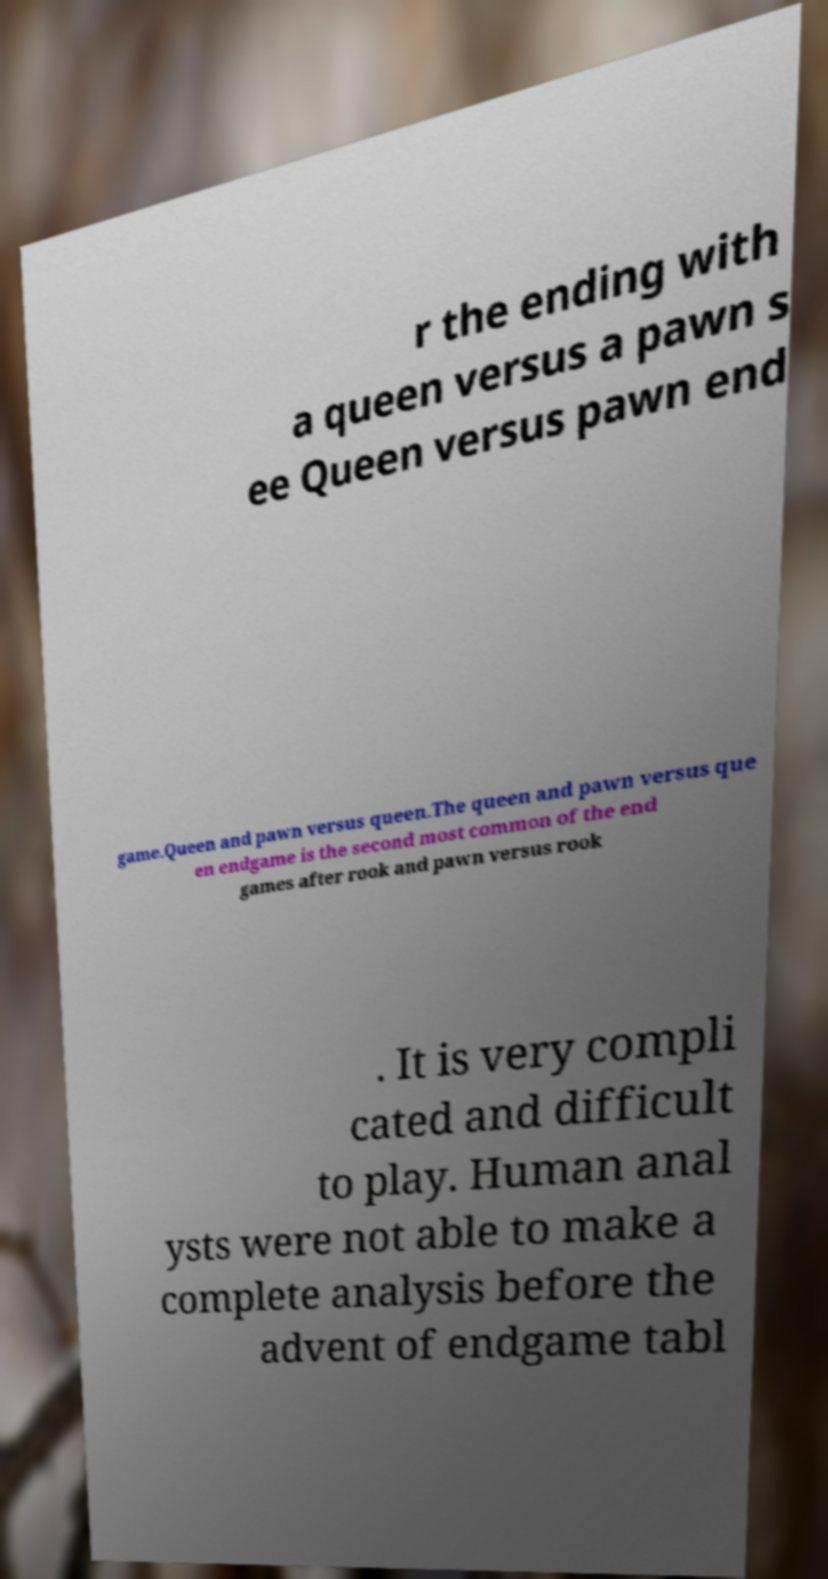Could you extract and type out the text from this image? r the ending with a queen versus a pawn s ee Queen versus pawn end game.Queen and pawn versus queen.The queen and pawn versus que en endgame is the second most common of the end games after rook and pawn versus rook . It is very compli cated and difficult to play. Human anal ysts were not able to make a complete analysis before the advent of endgame tabl 